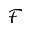Convert formula to latex. <formula><loc_0><loc_0><loc_500><loc_500>\mathcal { F }</formula> 